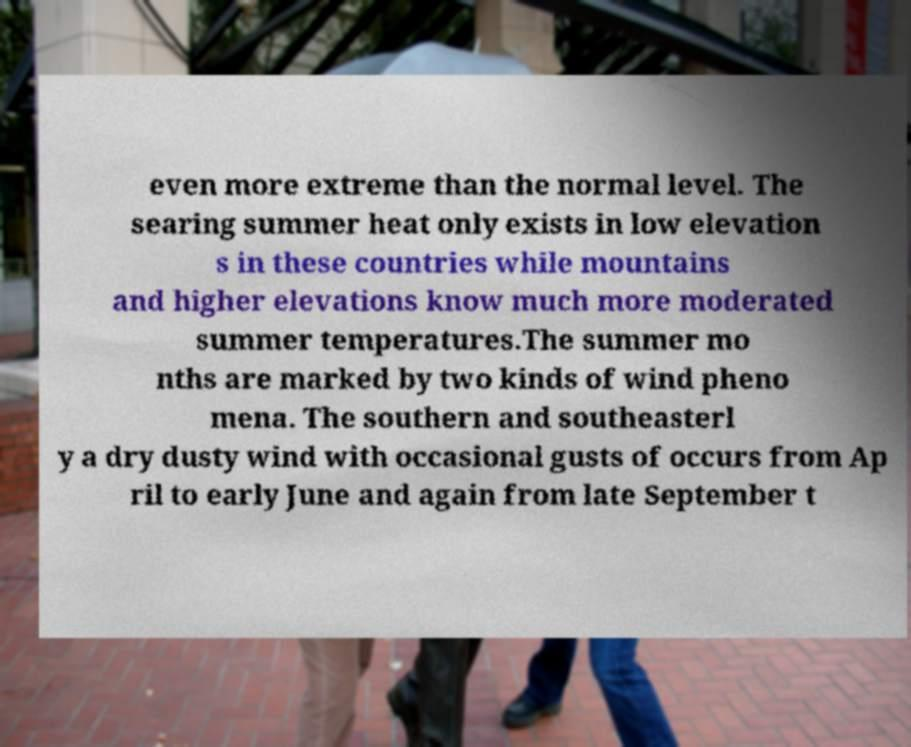Could you assist in decoding the text presented in this image and type it out clearly? even more extreme than the normal level. The searing summer heat only exists in low elevation s in these countries while mountains and higher elevations know much more moderated summer temperatures.The summer mo nths are marked by two kinds of wind pheno mena. The southern and southeasterl y a dry dusty wind with occasional gusts of occurs from Ap ril to early June and again from late September t 